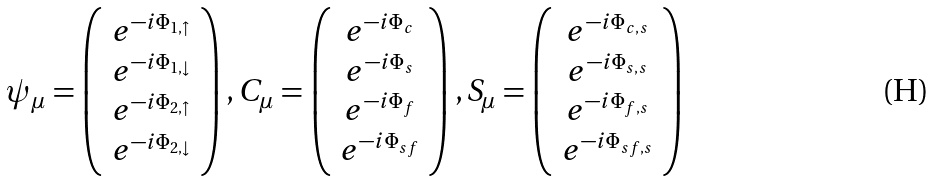<formula> <loc_0><loc_0><loc_500><loc_500>\psi _ { \mu } = \left ( \begin{array} { c } e ^ { - i \Phi _ { 1 , \uparrow } } \\ e ^ { - i \Phi _ { 1 , \downarrow } } \\ e ^ { - i \Phi _ { 2 , \uparrow } } \\ e ^ { - i \Phi _ { 2 , \downarrow } } \end{array} \right ) , C _ { \mu } = \left ( \begin{array} { c } e ^ { - i \Phi _ { c } } \\ e ^ { - i \Phi _ { s } } \\ e ^ { - i \Phi _ { f } } \\ e ^ { - i \Phi _ { s f } } \end{array} \right ) , S _ { \mu } = \left ( \begin{array} { c } e ^ { - i \Phi _ { c , s } } \\ e ^ { - i \Phi _ { s , s } } \\ e ^ { - i \Phi _ { f , s } } \\ e ^ { - i \Phi _ { s f , s } } \end{array} \right )</formula> 